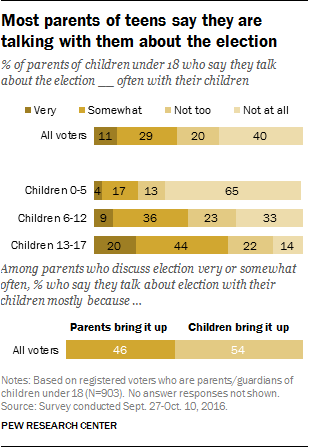List a handful of essential elements in this visual. Parents and children bring up the topic of 100 together. In the graph, 44% of the age group shown is made up of children aged 13-17. 